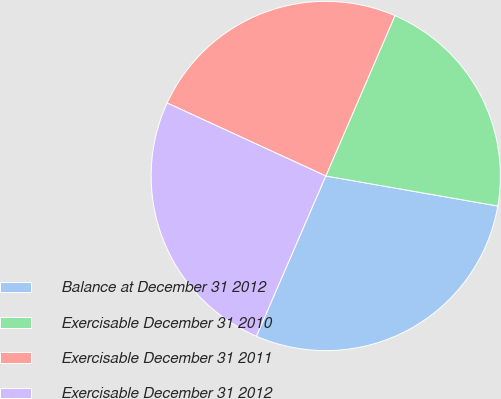Convert chart to OTSL. <chart><loc_0><loc_0><loc_500><loc_500><pie_chart><fcel>Balance at December 31 2012<fcel>Exercisable December 31 2010<fcel>Exercisable December 31 2011<fcel>Exercisable December 31 2012<nl><fcel>28.75%<fcel>21.27%<fcel>24.62%<fcel>25.36%<nl></chart> 